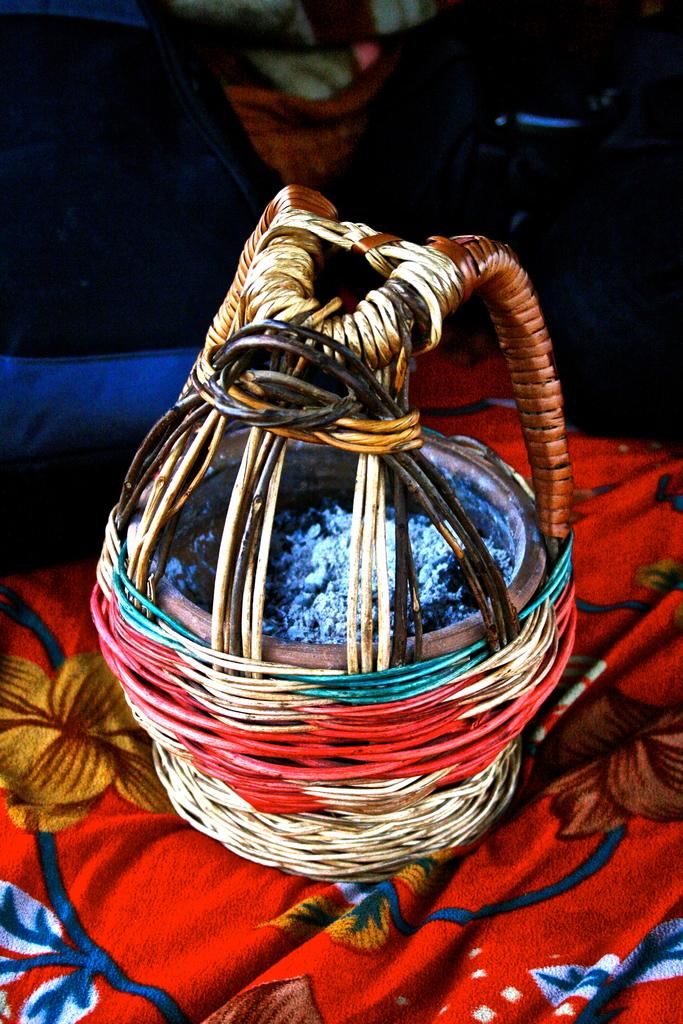What is contained within the basket in the image? There is a basket with items in it. What is the basket placed on? The basket is on a cloth. What can be seen in the background of the image? There is a background with a cloth and other objects. How many eggs are in the quiver in the image? There is no quiver or eggs present in the image. 